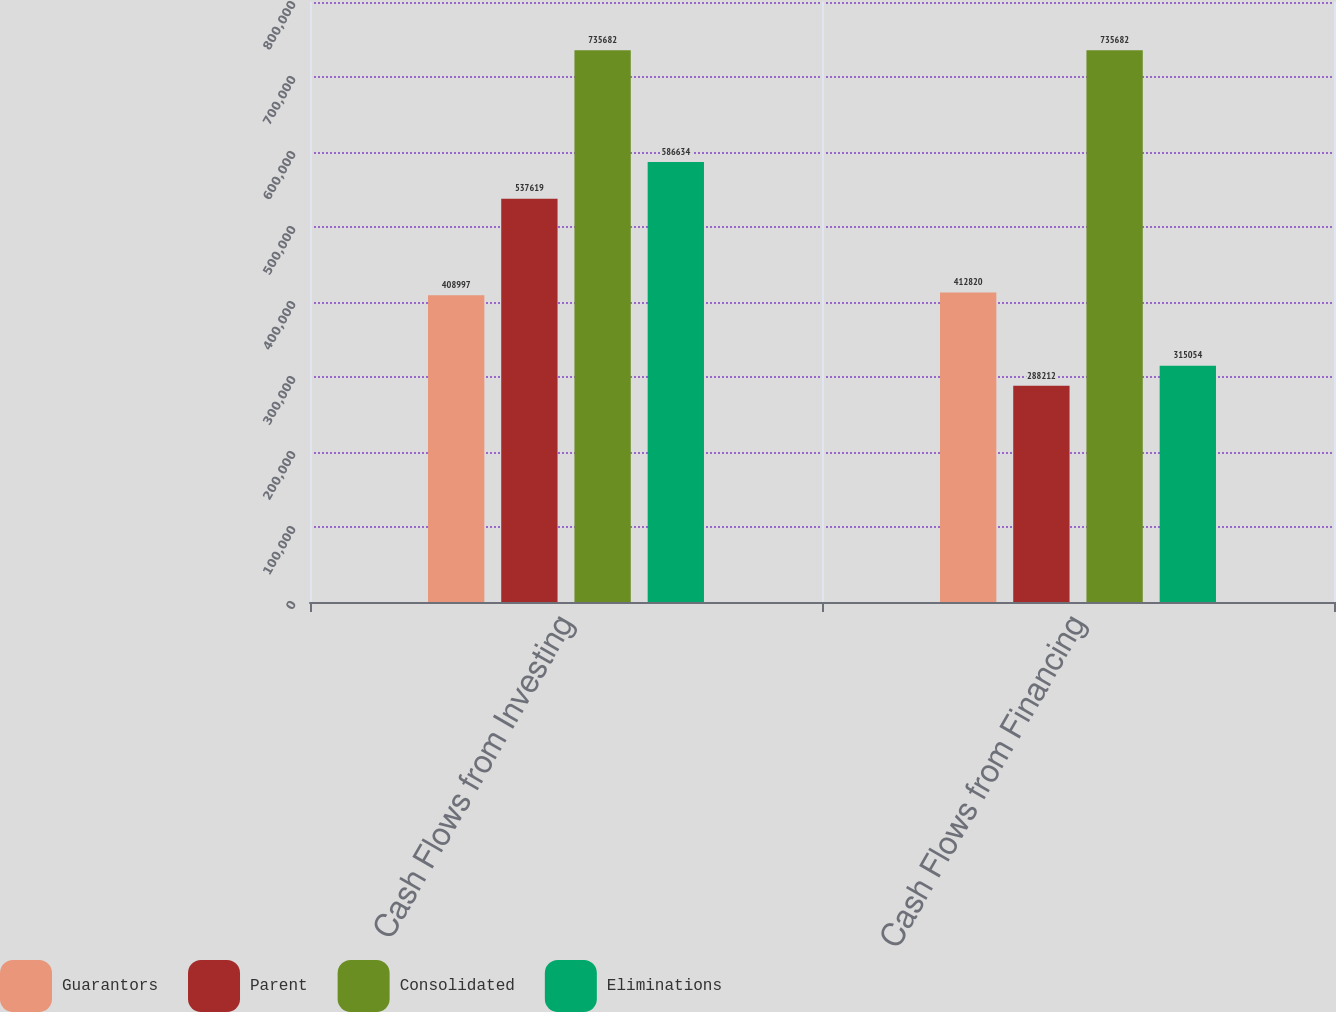Convert chart to OTSL. <chart><loc_0><loc_0><loc_500><loc_500><stacked_bar_chart><ecel><fcel>Cash Flows from Investing<fcel>Cash Flows from Financing<nl><fcel>Guarantors<fcel>408997<fcel>412820<nl><fcel>Parent<fcel>537619<fcel>288212<nl><fcel>Consolidated<fcel>735682<fcel>735682<nl><fcel>Eliminations<fcel>586634<fcel>315054<nl></chart> 